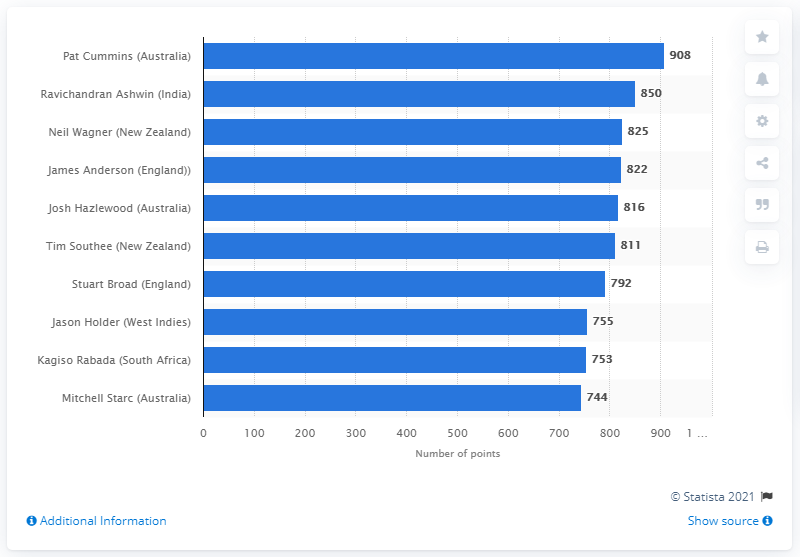Mention a couple of crucial points in this snapshot. Pat Cummins has 908 points. 